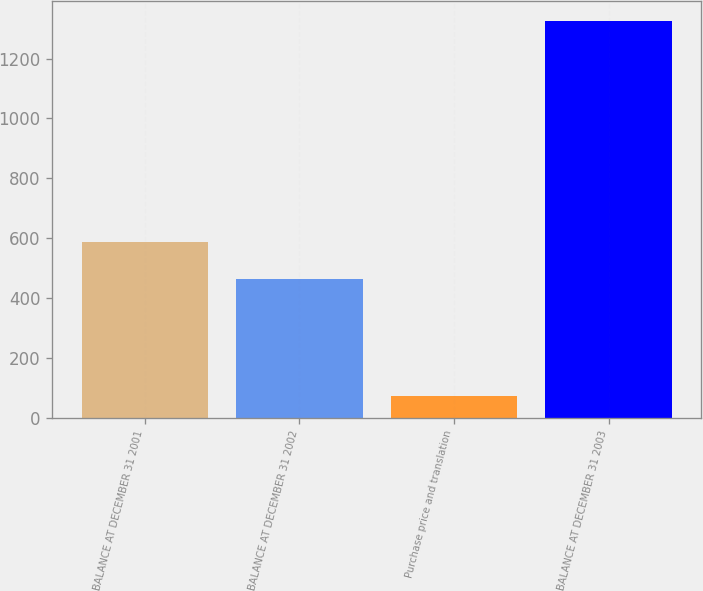<chart> <loc_0><loc_0><loc_500><loc_500><bar_chart><fcel>BALANCE AT DECEMBER 31 2001<fcel>BALANCE AT DECEMBER 31 2002<fcel>Purchase price and translation<fcel>BALANCE AT DECEMBER 31 2003<nl><fcel>587.4<fcel>462<fcel>72<fcel>1326<nl></chart> 